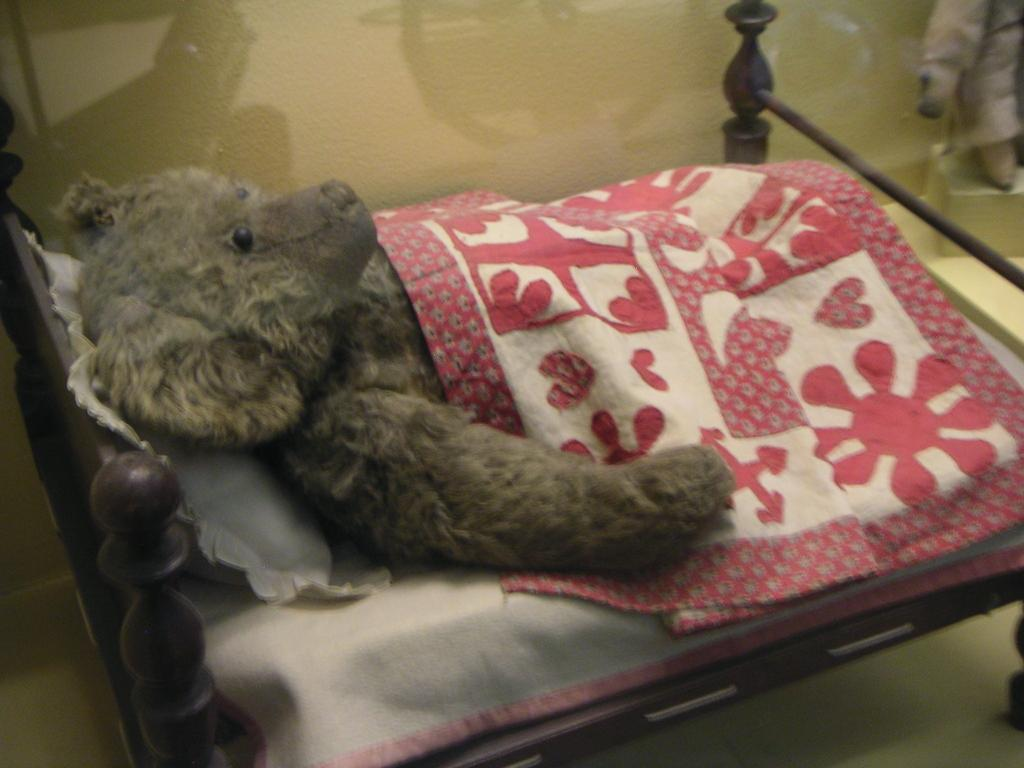What is the main subject of the image? The main subject of the image is a teddy doll. How is the teddy doll positioned in the image? The teddy doll is wrapped in a blanket and on a small bed. What else can be seen on the bed? There is a pillow on the bed. What type of zinc is present in the image? There is no zinc present in the image; it features a teddy doll wrapped in a blanket on a small bed with a pillow. How does the teddy doll walk on the side of the bed? The teddy doll does not walk in the image; it is wrapped in a blanket and stationary on the bed. 